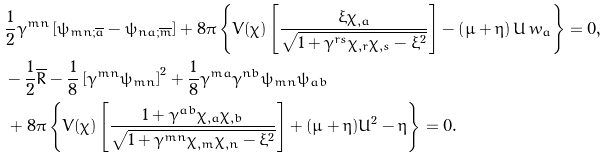<formula> <loc_0><loc_0><loc_500><loc_500>& \frac { 1 } { 2 } \gamma ^ { m n } \left [ \psi _ { m n ; \overline { a } } - \psi _ { n a ; \overline { m } } \right ] + 8 \pi \left \{ V ( \chi ) \left [ \frac { \xi \chi _ { , a } } { \sqrt { 1 + \gamma ^ { r s } \chi _ { , r } \chi _ { , s } - \xi ^ { 2 } } } \right ] - \left ( \mu + \eta \right ) U \, w _ { a } \right \} = 0 , \\ & - \frac { 1 } { 2 } \overline { R } - \frac { 1 } { 8 } \left [ \gamma ^ { m n } \psi _ { m n } \right ] ^ { 2 } + \frac { 1 } { 8 } \gamma ^ { m a } \gamma ^ { n b } \psi _ { m n } \psi _ { a b } \\ & \, + 8 \pi \left \{ V ( \chi ) \left [ \frac { 1 + \gamma ^ { a b } \chi _ { , a } \chi _ { , b } } { \sqrt { 1 + \gamma ^ { m n } \chi _ { , m } \chi _ { , n } - \xi ^ { 2 } } } \right ] + ( \mu + \eta ) U ^ { 2 } - \eta \right \} = 0 .</formula> 